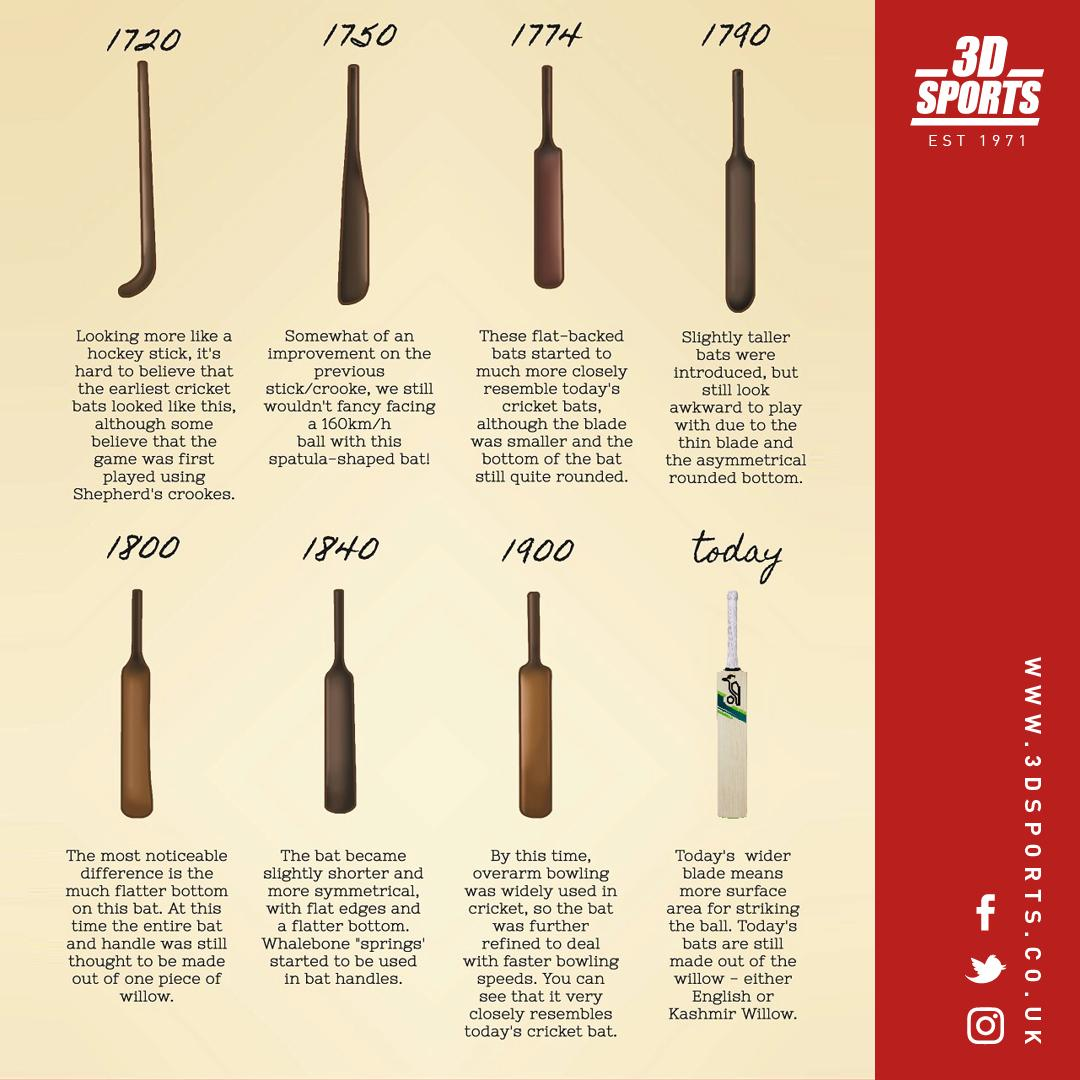Point out several critical features in this image. The game of cricket was played using flat-backed bats in the year 1774. In 1840, the use of whalebone in bat handles began. In 1720, the game of cricket was played using Shepherd's Crookes. In the year 1750, a cricket game was played using a bat shaped like a spatula. 